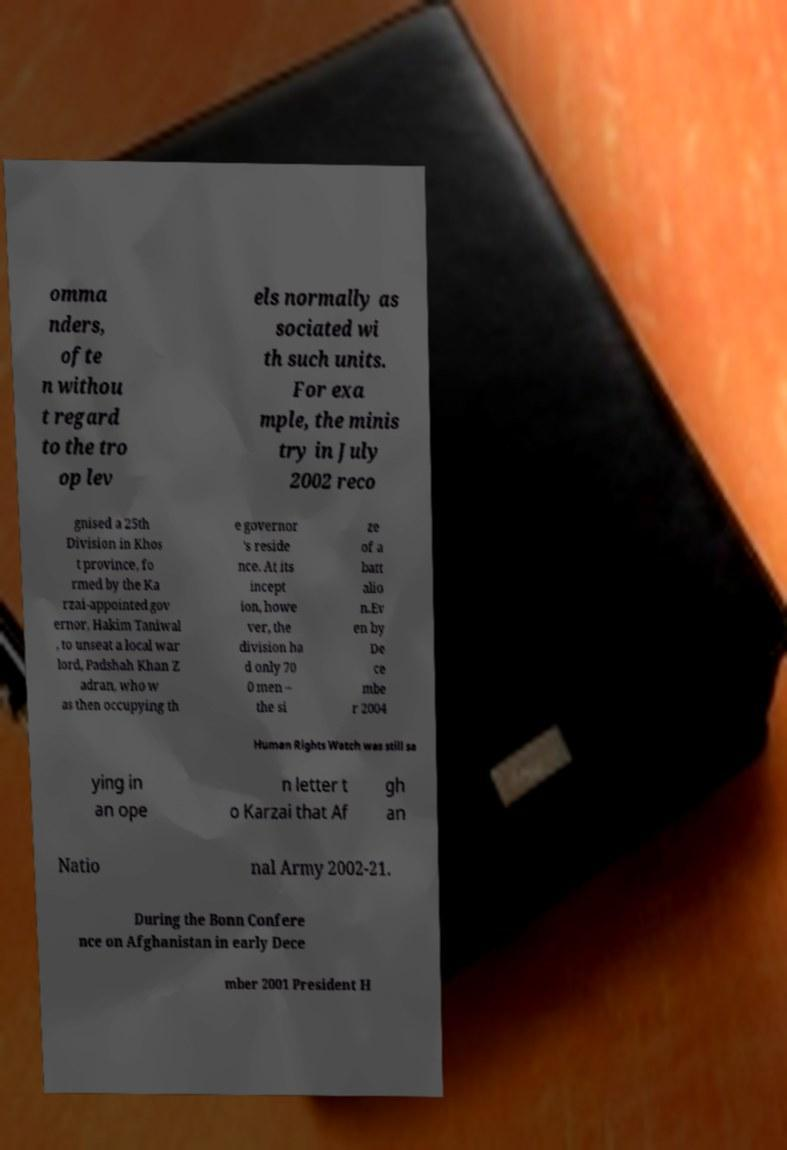I need the written content from this picture converted into text. Can you do that? omma nders, ofte n withou t regard to the tro op lev els normally as sociated wi th such units. For exa mple, the minis try in July 2002 reco gnised a 25th Division in Khos t province, fo rmed by the Ka rzai-appointed gov ernor, Hakim Taniwal , to unseat a local war lord, Padshah Khan Z adran, who w as then occupying th e governor 's reside nce. At its incept ion, howe ver, the division ha d only 70 0 men – the si ze of a batt alio n.Ev en by De ce mbe r 2004 Human Rights Watch was still sa ying in an ope n letter t o Karzai that Af gh an Natio nal Army 2002-21. During the Bonn Confere nce on Afghanistan in early Dece mber 2001 President H 